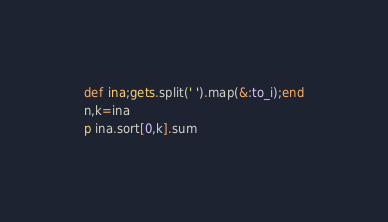<code> <loc_0><loc_0><loc_500><loc_500><_Ruby_>def ina;gets.split(' ').map(&:to_i);end
n,k=ina
p ina.sort[0,k].sum</code> 